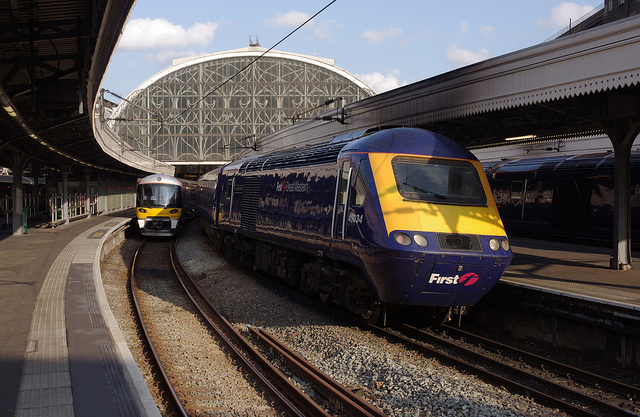<image>Is this a British train? I am not sure if this is a British train. Answers vary between yes and no. Is this a British train? I am not sure if this is a British train. It can be both British or not. 